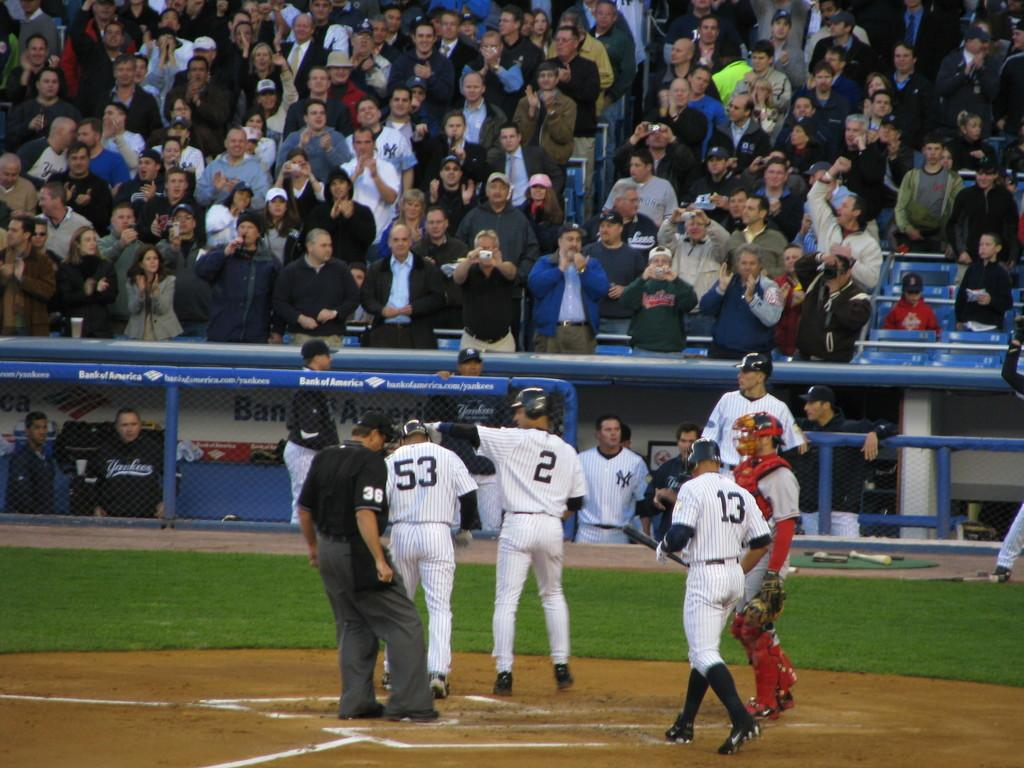<image>
Offer a succinct explanation of the picture presented. Several players, including jersey numbers 53, 2, and 13, converge at home plate. 